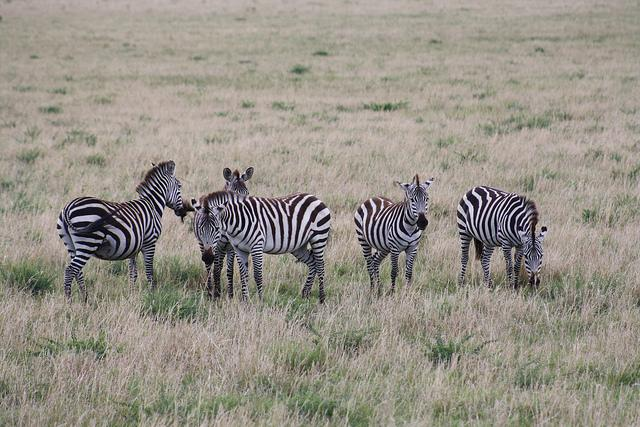How many zebras are standing in the middle of the open field?

Choices:
A) four
B) six
C) five
D) two five 